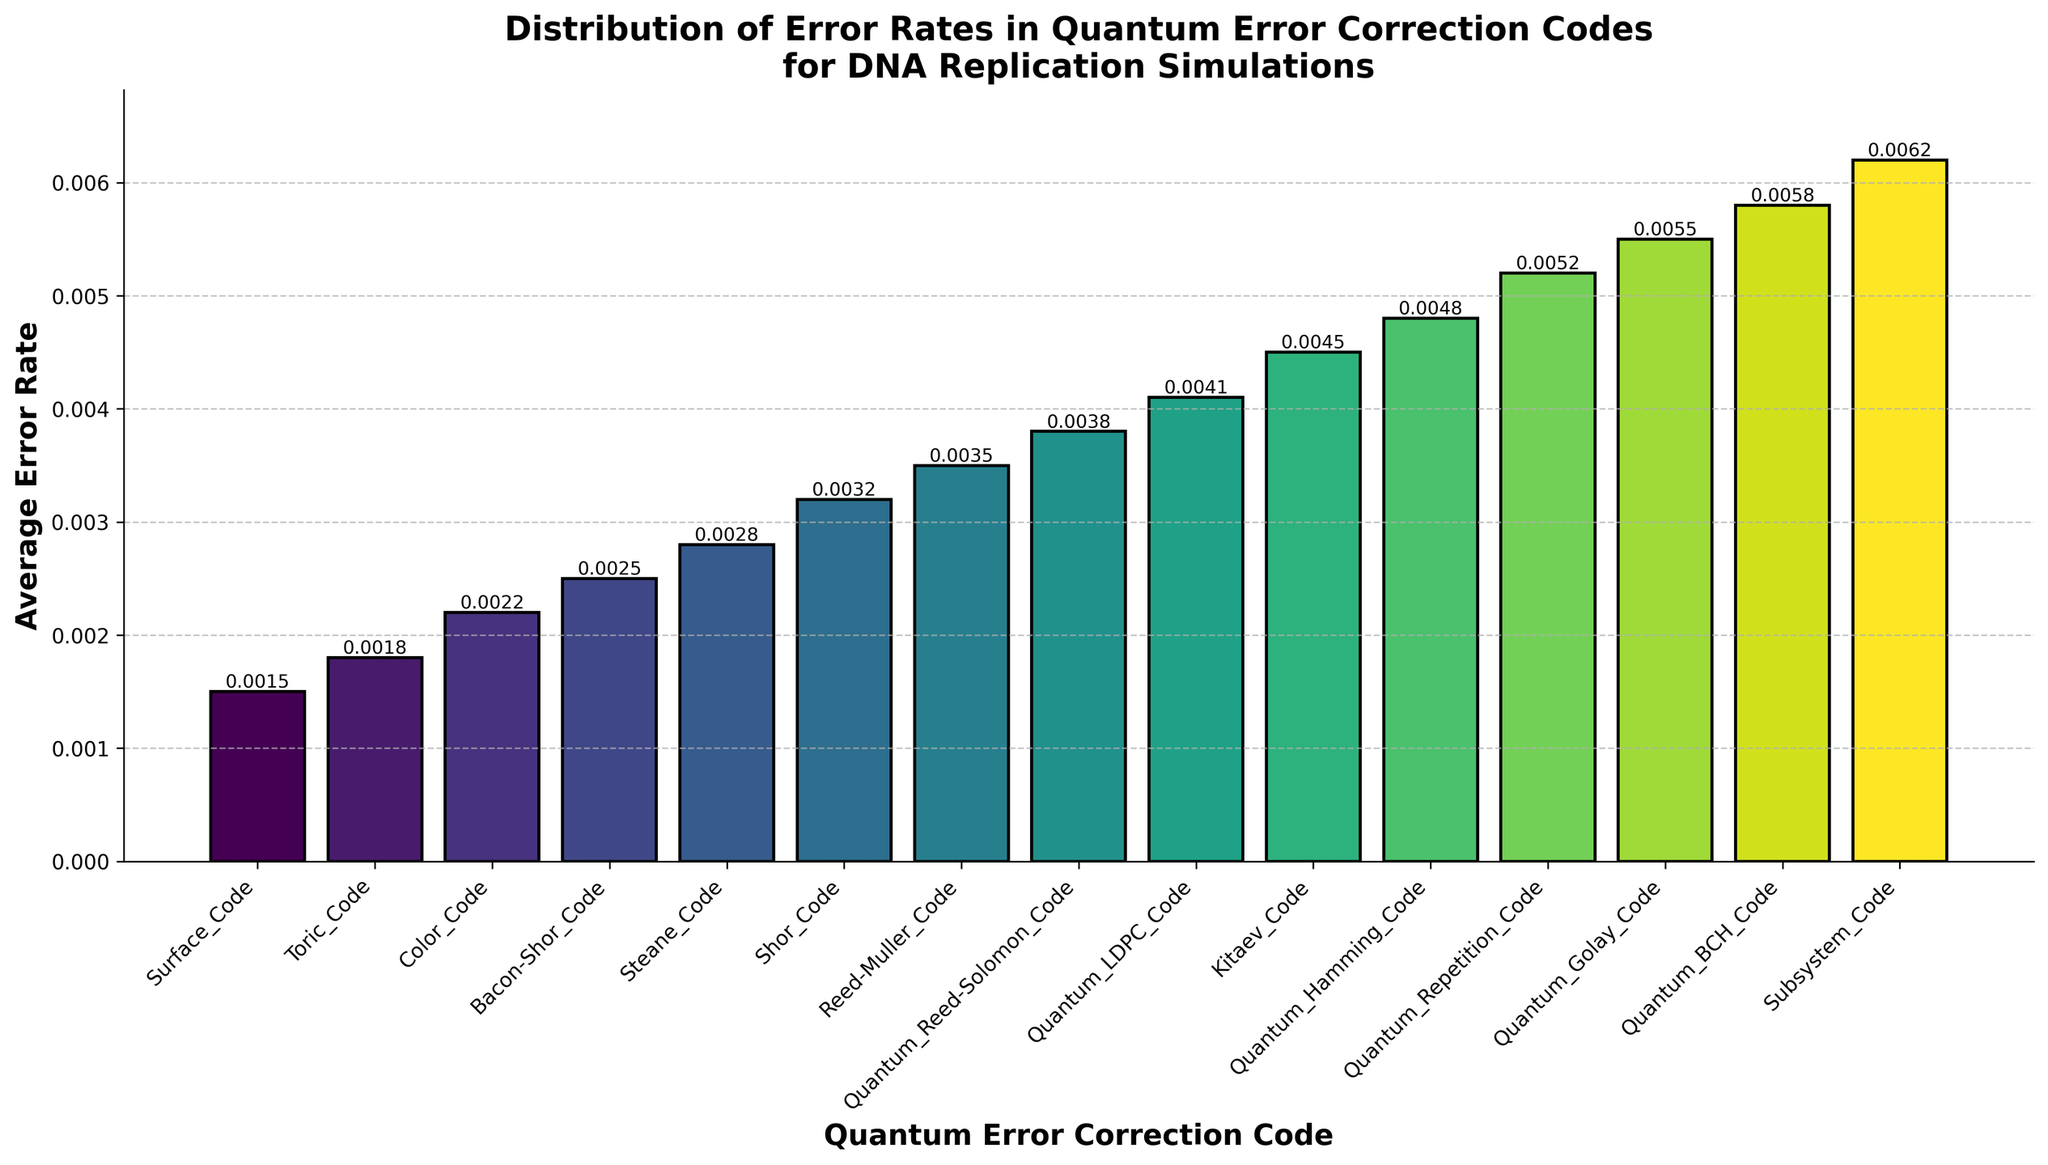What is the average error rate of the Surface Code? The average error rate is depicted by the height of the bar corresponding to the Surface Code. By looking at the figure, the error rate for the Surface Code is 0.0015.
Answer: 0.0015 Which quantum error correction code has the highest average error rate? We can identify the bar with the greatest height. The Quantum BCH Code has the highest average error rate in the figure, which is 0.0062.
Answer: Subsystem Code Compare the error rates of the Surface Code and the Toric Code. Which one is lower? The Surface Code has an error rate of 0.0015, and the Toric Code has an error rate of 0.0018. Since 0.0015 is less than 0.0018, the Surface Code has a lower error rate.
Answer: Surface Code How many quantum error correction codes have an average error rate higher than 0.003? Based on the heights of the bars, the codes with average error rates higher than 0.003 are Shor Code, Reed-Muller Code, Quantum Reed-Solomon Code, Quantum LDPC Code, Kitaev Code, Quantum Hamming Code, Quantum Repetition Code, Quantum Golay Code, Quantum BCH Code, and Subsystem Code. There are 10 such codes.
Answer: 10 Rank the first three codes with the lowest average error rates. By visually comparing the heights of the bars, the first three codes with the lowest average error rates are Surface Code (0.0015), Toric Code (0.0018), and Color Code (0.0022).
Answer: Surface Code, Toric Code, Color Code What is the difference in average error rates between the Shor Code and the Steane Code? The Shor Code has an average error rate of 0.0032, and the Steane Code is 0.0028. The difference is 0.0032 - 0.0028.
Answer: 0.0004 Which code is positioned fourth if you arrange them by increasing error rates? By arranging the codes by increasing error rates, we get Surface Code (1st), Toric Code (2nd), Color Code (3rd), and Bacon-Shor Code (4th).
Answer: Bacon-Shor Code Compare the error rates of the Subsystem Code and the Quantum Reed-Solomon Code. How much higher is the Subsystem Code's error rate? Subsystem Code has an error rate of 0.0062, and Quantum Reed-Solomon Code has an error rate of 0.0038. The Subsystem Code's error rate is 0.0062 - 0.0038 higher.
Answer: 0.0024 What is the median error rate of the quantum error correction codes? To find the median, sort the error rates in order and find the middle value. The median of the provided error rates falls on the Quantum Reed-Solomon Code at 0.0038.
Answer: 0.0038 